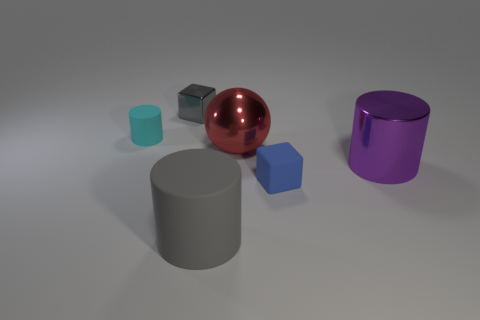There is a small blue thing that is made of the same material as the large gray cylinder; what shape is it?
Your answer should be compact. Cube. How many other objects are there of the same shape as the large gray rubber thing?
Offer a very short reply. 2. What number of purple things are either cylinders or small metallic cubes?
Your response must be concise. 1. Does the big rubber object have the same shape as the small gray metallic thing?
Your answer should be very brief. No. There is a large thing behind the purple object; are there any cubes that are to the left of it?
Your answer should be compact. Yes. Is the number of cylinders that are to the left of the gray block the same as the number of big spheres?
Give a very brief answer. Yes. What number of other things are there of the same size as the cyan cylinder?
Offer a terse response. 2. Is the small gray block right of the small cyan thing made of the same material as the red thing that is on the right side of the tiny gray metal thing?
Provide a succinct answer. Yes. What is the size of the gray object that is in front of the shiny object that is to the right of the red sphere?
Provide a succinct answer. Large. Are there any large rubber cylinders that have the same color as the small shiny object?
Provide a succinct answer. Yes. 